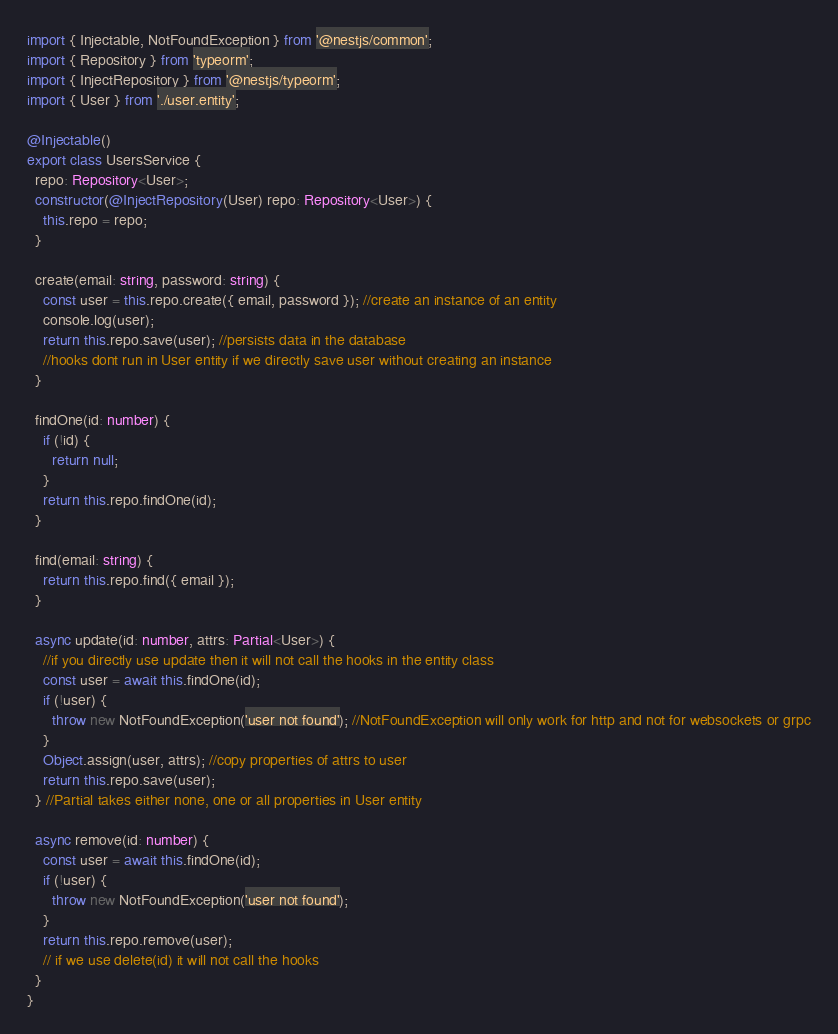Convert code to text. <code><loc_0><loc_0><loc_500><loc_500><_TypeScript_>import { Injectable, NotFoundException } from '@nestjs/common';
import { Repository } from 'typeorm';
import { InjectRepository } from '@nestjs/typeorm';
import { User } from './user.entity';

@Injectable()
export class UsersService {
  repo: Repository<User>;
  constructor(@InjectRepository(User) repo: Repository<User>) {
    this.repo = repo;
  }

  create(email: string, password: string) {
    const user = this.repo.create({ email, password }); //create an instance of an entity
    console.log(user);
    return this.repo.save(user); //persists data in the database
    //hooks dont run in User entity if we directly save user without creating an instance
  }

  findOne(id: number) {
    if (!id) {
      return null;
    }
    return this.repo.findOne(id);
  }

  find(email: string) {
    return this.repo.find({ email });
  }

  async update(id: number, attrs: Partial<User>) {
    //if you directly use update then it will not call the hooks in the entity class
    const user = await this.findOne(id);
    if (!user) {
      throw new NotFoundException('user not found'); //NotFoundException will only work for http and not for websockets or grpc
    }
    Object.assign(user, attrs); //copy properties of attrs to user
    return this.repo.save(user);
  } //Partial takes either none, one or all properties in User entity

  async remove(id: number) {
    const user = await this.findOne(id);
    if (!user) {
      throw new NotFoundException('user not found');
    }
    return this.repo.remove(user);
    // if we use delete(id) it will not call the hooks
  }
}
</code> 